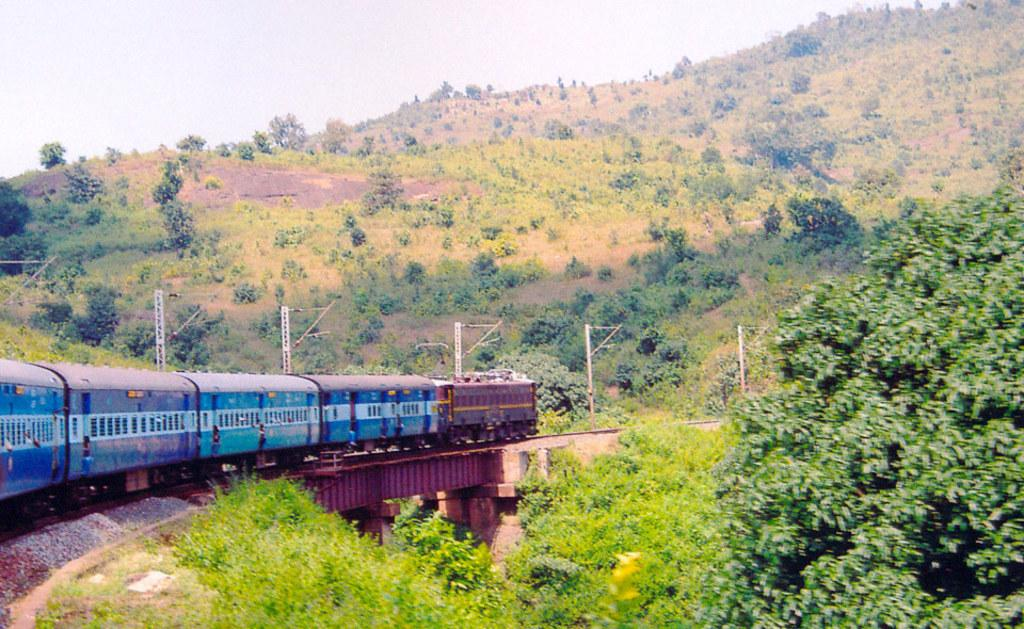What is the main subject of the image? The main subject of the image is a train. Where is the train located in the image? The train is on a train track. What can be seen in the background of the image? Mountains are visible in the image. What types of vegetation are present on the mountains? Trees and plants are present on the mountains. What type of vegetable is being grown on the train in the image? There are no vegetables present in the image, and the train is not being used for growing vegetables. 